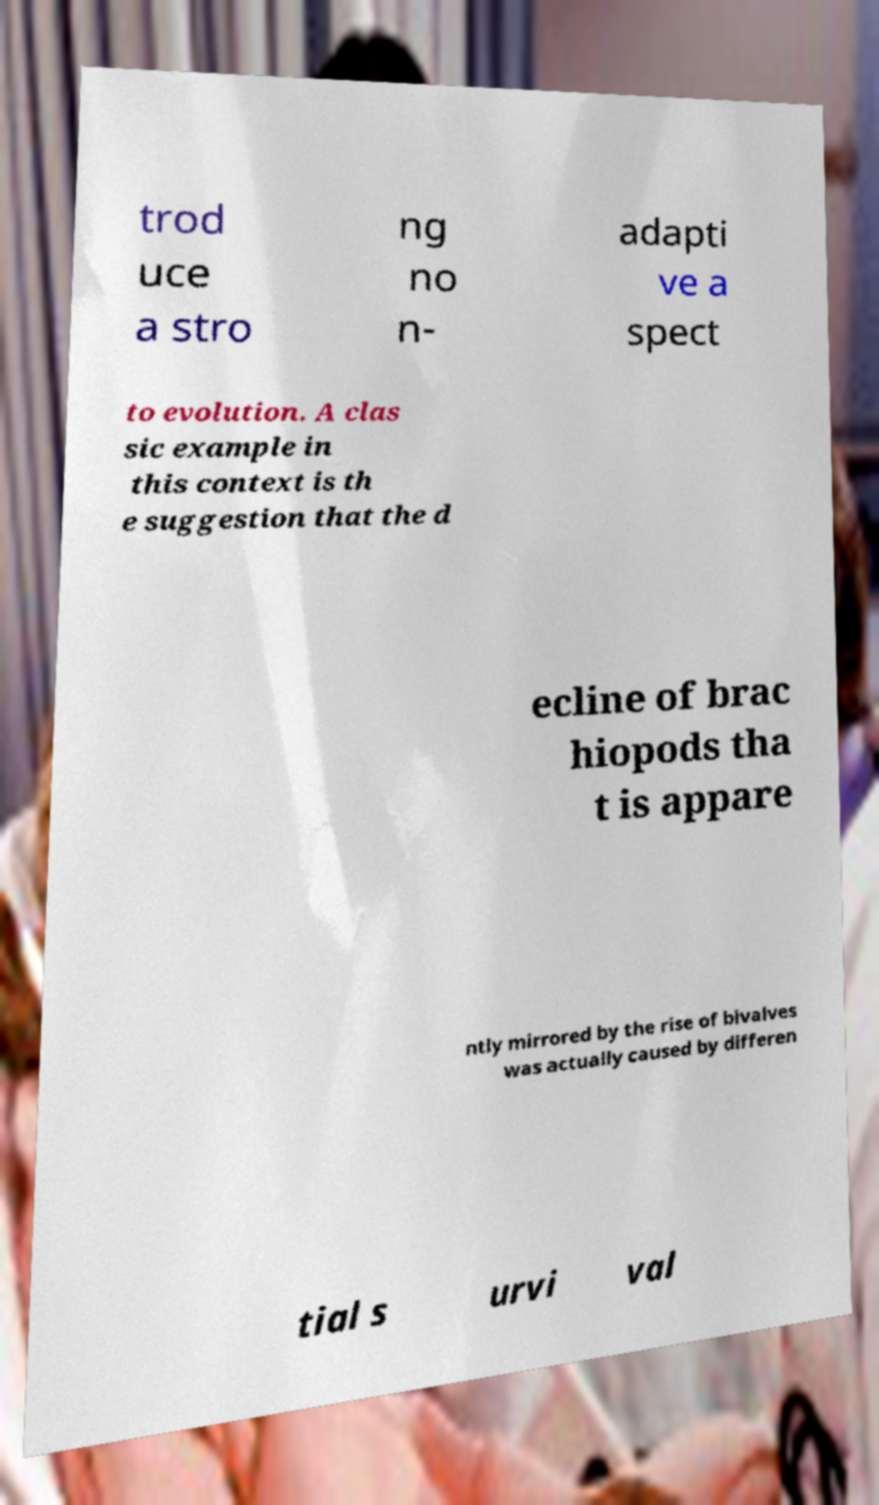Could you assist in decoding the text presented in this image and type it out clearly? trod uce a stro ng no n- adapti ve a spect to evolution. A clas sic example in this context is th e suggestion that the d ecline of brac hiopods tha t is appare ntly mirrored by the rise of bivalves was actually caused by differen tial s urvi val 